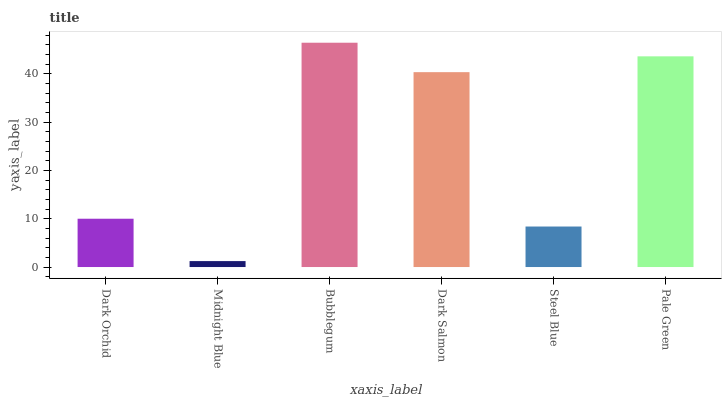Is Midnight Blue the minimum?
Answer yes or no. Yes. Is Bubblegum the maximum?
Answer yes or no. Yes. Is Bubblegum the minimum?
Answer yes or no. No. Is Midnight Blue the maximum?
Answer yes or no. No. Is Bubblegum greater than Midnight Blue?
Answer yes or no. Yes. Is Midnight Blue less than Bubblegum?
Answer yes or no. Yes. Is Midnight Blue greater than Bubblegum?
Answer yes or no. No. Is Bubblegum less than Midnight Blue?
Answer yes or no. No. Is Dark Salmon the high median?
Answer yes or no. Yes. Is Dark Orchid the low median?
Answer yes or no. Yes. Is Midnight Blue the high median?
Answer yes or no. No. Is Bubblegum the low median?
Answer yes or no. No. 